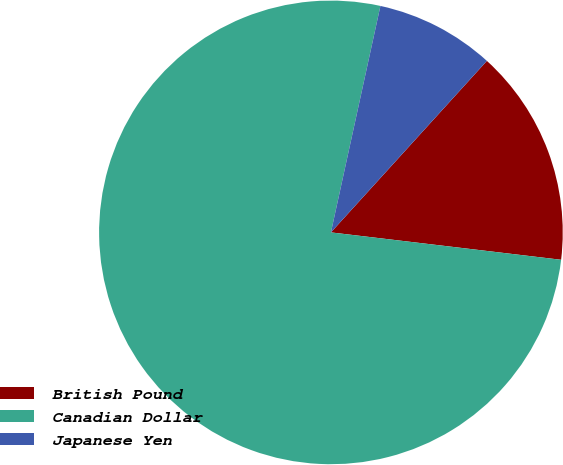<chart> <loc_0><loc_0><loc_500><loc_500><pie_chart><fcel>British Pound<fcel>Canadian Dollar<fcel>Japanese Yen<nl><fcel>15.14%<fcel>76.54%<fcel>8.32%<nl></chart> 